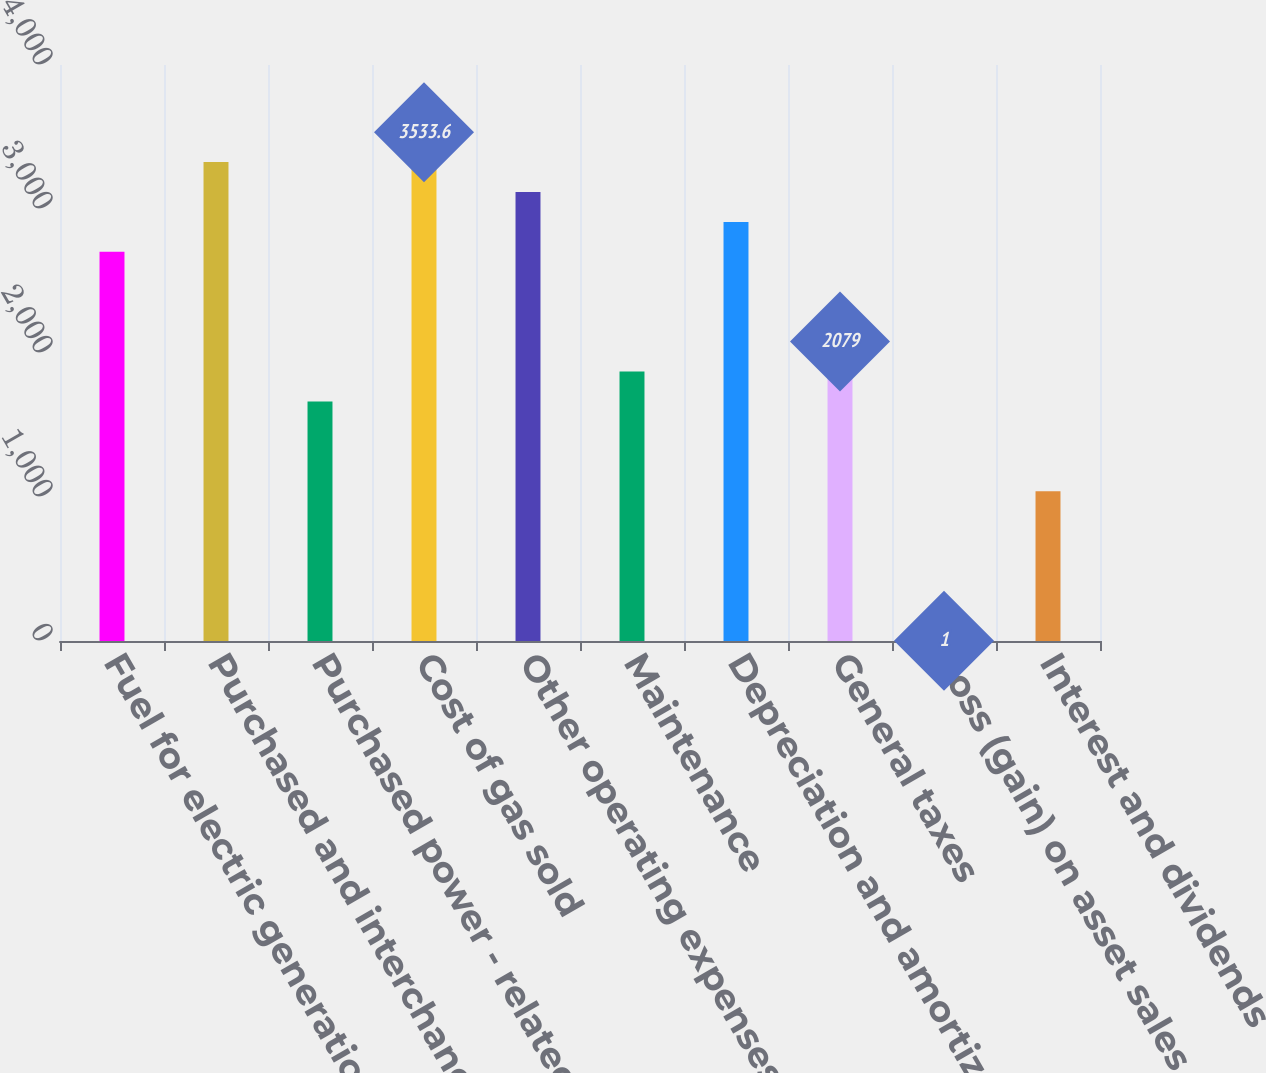Convert chart. <chart><loc_0><loc_0><loc_500><loc_500><bar_chart><fcel>Fuel for electric generation<fcel>Purchased and interchange<fcel>Purchased power - related<fcel>Cost of gas sold<fcel>Other operating expenses<fcel>Maintenance<fcel>Depreciation and amortization<fcel>General taxes<fcel>Loss (gain) on asset sales net<fcel>Interest and dividends<nl><fcel>2702.4<fcel>3325.8<fcel>1663.4<fcel>3533.6<fcel>3118<fcel>1871.2<fcel>2910.2<fcel>2079<fcel>1<fcel>1040<nl></chart> 